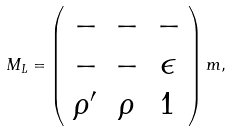<formula> <loc_0><loc_0><loc_500><loc_500>M _ { L } = \left ( \begin{array} { c c c } - & - & - \\ - & - & \epsilon \\ \rho ^ { \prime } & \rho & 1 \end{array} \right ) m ,</formula> 